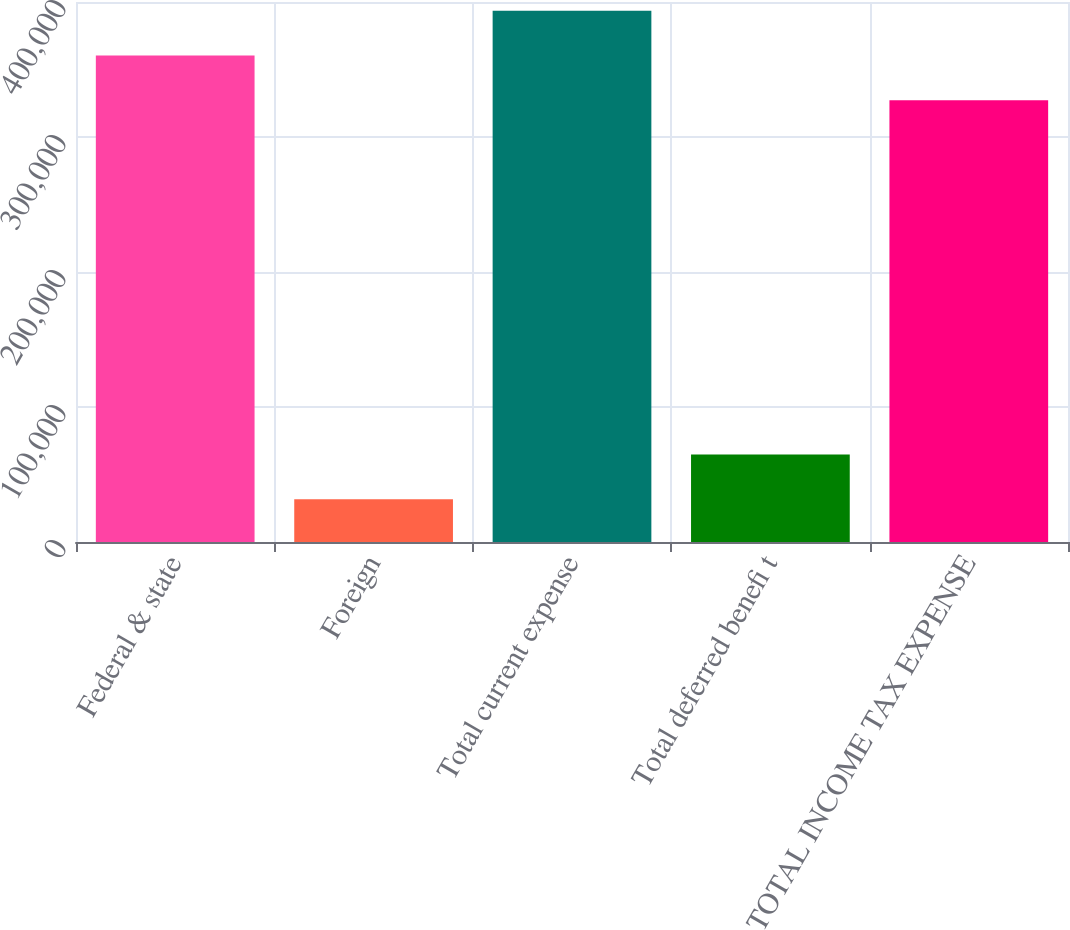<chart> <loc_0><loc_0><loc_500><loc_500><bar_chart><fcel>Federal & state<fcel>Foreign<fcel>Total current expense<fcel>Total deferred benefi t<fcel>TOTAL INCOME TAX EXPENSE<nl><fcel>360407<fcel>31683<fcel>393547<fcel>64823<fcel>327267<nl></chart> 